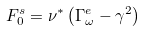<formula> <loc_0><loc_0><loc_500><loc_500>F _ { 0 } ^ { s } = \nu ^ { * } \left ( \Gamma _ { \omega } ^ { e } - \gamma ^ { 2 } \right )</formula> 